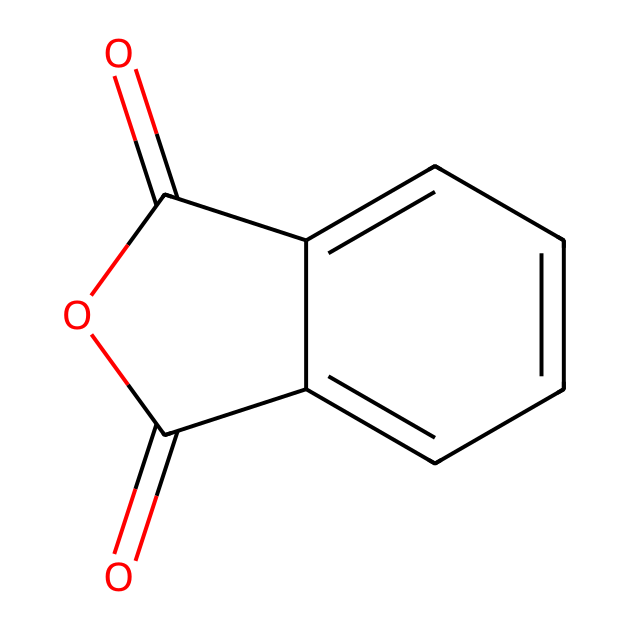What is the name of the chemical represented? The SMILES representation corresponds to the structure of phthalic anhydride, which can be deduced from recognizing the anhydride functional group and the aromatic ring presence in the formula.
Answer: phthalic anhydride How many carbon atoms are present in phthalic anhydride? By analyzing the structure derived from the SMILES, we can identify there are 8 carbon atoms in total, including those in both the anhydride groups and the aromatic ring.
Answer: 8 What type of functional group is present in phthalic anhydride? The presence of the carbonyl groups (C=O) adjacent to an oxygen in a cyclic structure indicates the functional group is an anhydride, specifically an acid anhydride.
Answer: anhydride What is the number of oxygen atoms in phthalic anhydride? From the structural interpretation of the SMILES, we determine that there are 3 oxygen atoms present: 2 in the anhydride groups and 1 in the cycle.
Answer: 3 Does phthalic anhydride contain any double bonds? Yes, the structure indicates the presence of carbonyl (C=O) double bonds in the anhydride.
Answer: yes Is phthalic anhydride aromatic? The structure shows a benzene ring, which confirms that it has an aromatic character due to the cyclic, conjugated system of electrons.
Answer: yes 